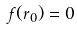<formula> <loc_0><loc_0><loc_500><loc_500>f ( r _ { 0 } ) = 0</formula> 